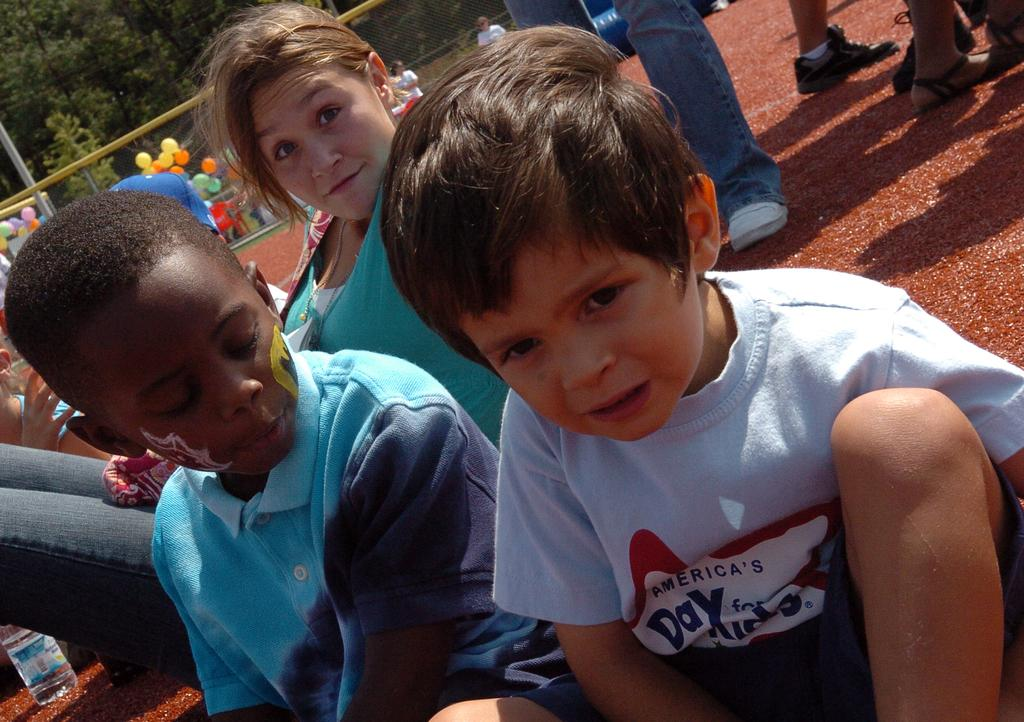Who is present in the image? There are kids and a lady in the image. What are they sitting on? They are sitting on a red mat. What can be seen in the background of the image? There are people walking, people standing, and trees in the background of the image. What else is present in the image? There are balloons in the image. What type of drink is being served to the kids in the image? There is no drink present in the image; it only shows kids, a lady, a red mat, people in the background, and balloons. 